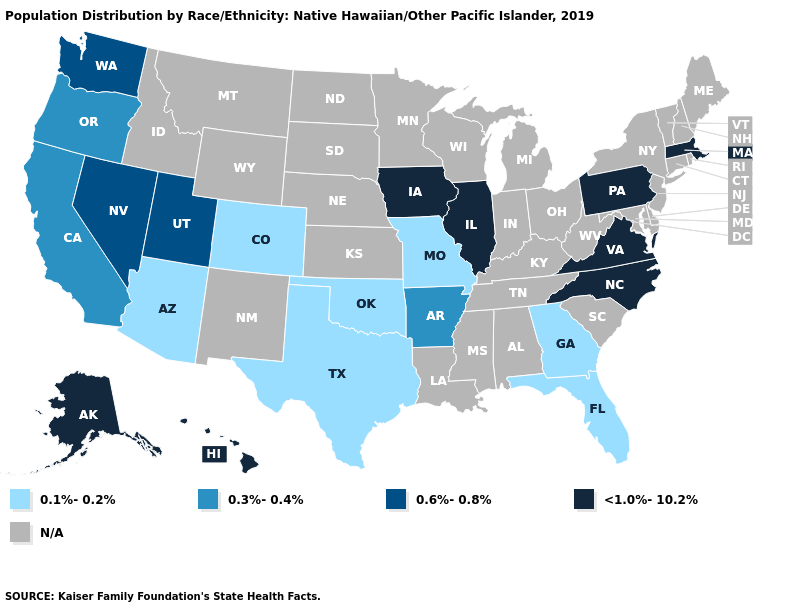Among the states that border Louisiana , does Arkansas have the lowest value?
Short answer required. No. Name the states that have a value in the range 0.3%-0.4%?
Answer briefly. Arkansas, California, Oregon. Name the states that have a value in the range 0.6%-0.8%?
Give a very brief answer. Nevada, Utah, Washington. Which states have the lowest value in the South?
Quick response, please. Florida, Georgia, Oklahoma, Texas. Name the states that have a value in the range N/A?
Keep it brief. Alabama, Connecticut, Delaware, Idaho, Indiana, Kansas, Kentucky, Louisiana, Maine, Maryland, Michigan, Minnesota, Mississippi, Montana, Nebraska, New Hampshire, New Jersey, New Mexico, New York, North Dakota, Ohio, Rhode Island, South Carolina, South Dakota, Tennessee, Vermont, West Virginia, Wisconsin, Wyoming. What is the value of New Jersey?
Answer briefly. N/A. Is the legend a continuous bar?
Quick response, please. No. Name the states that have a value in the range <1.0%-10.2%?
Quick response, please. Alaska, Hawaii, Illinois, Iowa, Massachusetts, North Carolina, Pennsylvania, Virginia. Does the first symbol in the legend represent the smallest category?
Quick response, please. Yes. Among the states that border Texas , which have the highest value?
Write a very short answer. Arkansas. Which states have the lowest value in the USA?
Write a very short answer. Arizona, Colorado, Florida, Georgia, Missouri, Oklahoma, Texas. What is the value of New Jersey?
Answer briefly. N/A. 